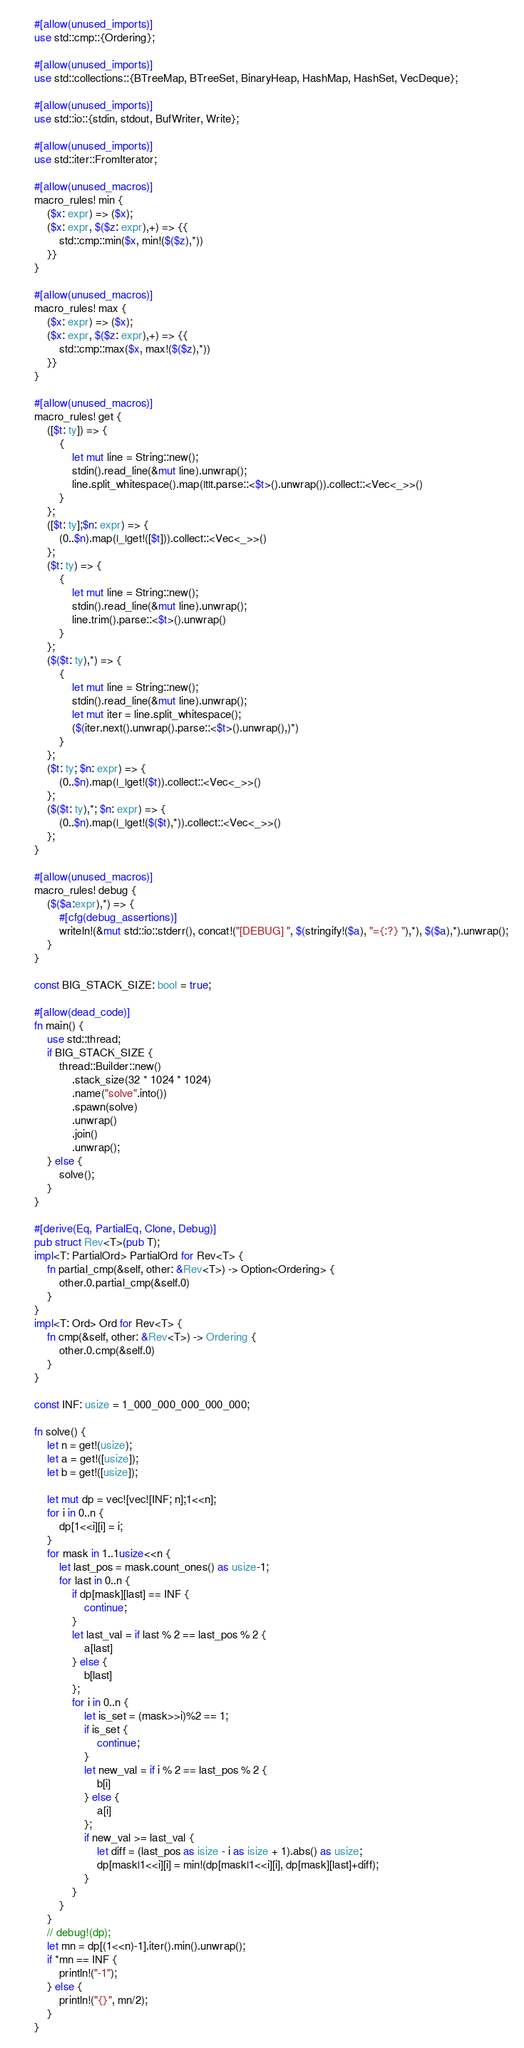Convert code to text. <code><loc_0><loc_0><loc_500><loc_500><_Rust_>#[allow(unused_imports)]
use std::cmp::{Ordering};

#[allow(unused_imports)]
use std::collections::{BTreeMap, BTreeSet, BinaryHeap, HashMap, HashSet, VecDeque};

#[allow(unused_imports)]
use std::io::{stdin, stdout, BufWriter, Write};

#[allow(unused_imports)]
use std::iter::FromIterator;

#[allow(unused_macros)]
macro_rules! min {
    ($x: expr) => ($x);
    ($x: expr, $($z: expr),+) => {{
        std::cmp::min($x, min!($($z),*))
    }}
}

#[allow(unused_macros)]
macro_rules! max {
    ($x: expr) => ($x);
    ($x: expr, $($z: expr),+) => {{
        std::cmp::max($x, max!($($z),*))
    }}
}

#[allow(unused_macros)]
macro_rules! get { 
    ([$t: ty]) => { 
        { 
            let mut line = String::new(); 
            stdin().read_line(&mut line).unwrap(); 
            line.split_whitespace().map(|t|t.parse::<$t>().unwrap()).collect::<Vec<_>>()
        }
    };
    ([$t: ty];$n: expr) => {
        (0..$n).map(|_|get!([$t])).collect::<Vec<_>>()
    };
    ($t: ty) => {
        {
            let mut line = String::new();
            stdin().read_line(&mut line).unwrap();
            line.trim().parse::<$t>().unwrap()
        }
    };
    ($($t: ty),*) => {
        { 
            let mut line = String::new();
            stdin().read_line(&mut line).unwrap();
            let mut iter = line.split_whitespace();
            ($(iter.next().unwrap().parse::<$t>().unwrap(),)*)
        }
    };
    ($t: ty; $n: expr) => {
        (0..$n).map(|_|get!($t)).collect::<Vec<_>>()
    };
    ($($t: ty),*; $n: expr) => {
        (0..$n).map(|_|get!($($t),*)).collect::<Vec<_>>()
    };
}

#[allow(unused_macros)]
macro_rules! debug {
    ($($a:expr),*) => {
        #[cfg(debug_assertions)]
        writeln!(&mut std::io::stderr(), concat!("[DEBUG] ", $(stringify!($a), "={:?} "),*), $($a),*).unwrap();
    }
}

const BIG_STACK_SIZE: bool = true;

#[allow(dead_code)]
fn main() {
    use std::thread;
    if BIG_STACK_SIZE {
        thread::Builder::new()
            .stack_size(32 * 1024 * 1024)
            .name("solve".into())
            .spawn(solve)
            .unwrap()
            .join()
            .unwrap();
    } else {
        solve();
    }
}

#[derive(Eq, PartialEq, Clone, Debug)]
pub struct Rev<T>(pub T);
impl<T: PartialOrd> PartialOrd for Rev<T> {
    fn partial_cmp(&self, other: &Rev<T>) -> Option<Ordering> {
        other.0.partial_cmp(&self.0)
    }
}
impl<T: Ord> Ord for Rev<T> {
    fn cmp(&self, other: &Rev<T>) -> Ordering {
        other.0.cmp(&self.0)
    }
}

const INF: usize = 1_000_000_000_000_000;

fn solve() {
    let n = get!(usize);
    let a = get!([usize]);
    let b = get!([usize]);

    let mut dp = vec![vec![INF; n];1<<n];
    for i in 0..n {
        dp[1<<i][i] = i;
    }
    for mask in 1..1usize<<n {
        let last_pos = mask.count_ones() as usize-1;
        for last in 0..n {
            if dp[mask][last] == INF {
                continue;
            }
            let last_val = if last % 2 == last_pos % 2 {
                a[last]
            } else {
                b[last]
            };
            for i in 0..n {
                let is_set = (mask>>i)%2 == 1;
                if is_set {
                    continue;
                }
                let new_val = if i % 2 == last_pos % 2 {
                    b[i]
                } else {
                    a[i]
                };
                if new_val >= last_val {
                    let diff = (last_pos as isize - i as isize + 1).abs() as usize;
                    dp[mask|1<<i][i] = min!(dp[mask|1<<i][i], dp[mask][last]+diff);
                }
            }
        }
    }
    // debug!(dp);
    let mn = dp[(1<<n)-1].iter().min().unwrap();
    if *mn == INF {
        println!("-1");
    } else {
        println!("{}", mn/2);
    }
}
</code> 